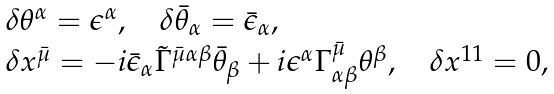Convert formula to latex. <formula><loc_0><loc_0><loc_500><loc_500>\begin{array} { l } { { \delta \theta ^ { \alpha } = \epsilon ^ { \alpha } , \quad \delta \bar { \theta } _ { \alpha } = \bar { \epsilon } _ { \alpha } , } } \\ { { \delta x ^ { \bar { \mu } } = - i \bar { \epsilon } _ { \alpha } \tilde { \Gamma } ^ { { \bar { \mu } } \alpha \beta } \bar { \theta } _ { \beta } + i \epsilon ^ { \alpha } \Gamma _ { \alpha \beta } ^ { \bar { \mu } } \theta ^ { \beta } , \quad \delta x ^ { 1 1 } = 0 , } } \end{array}</formula> 